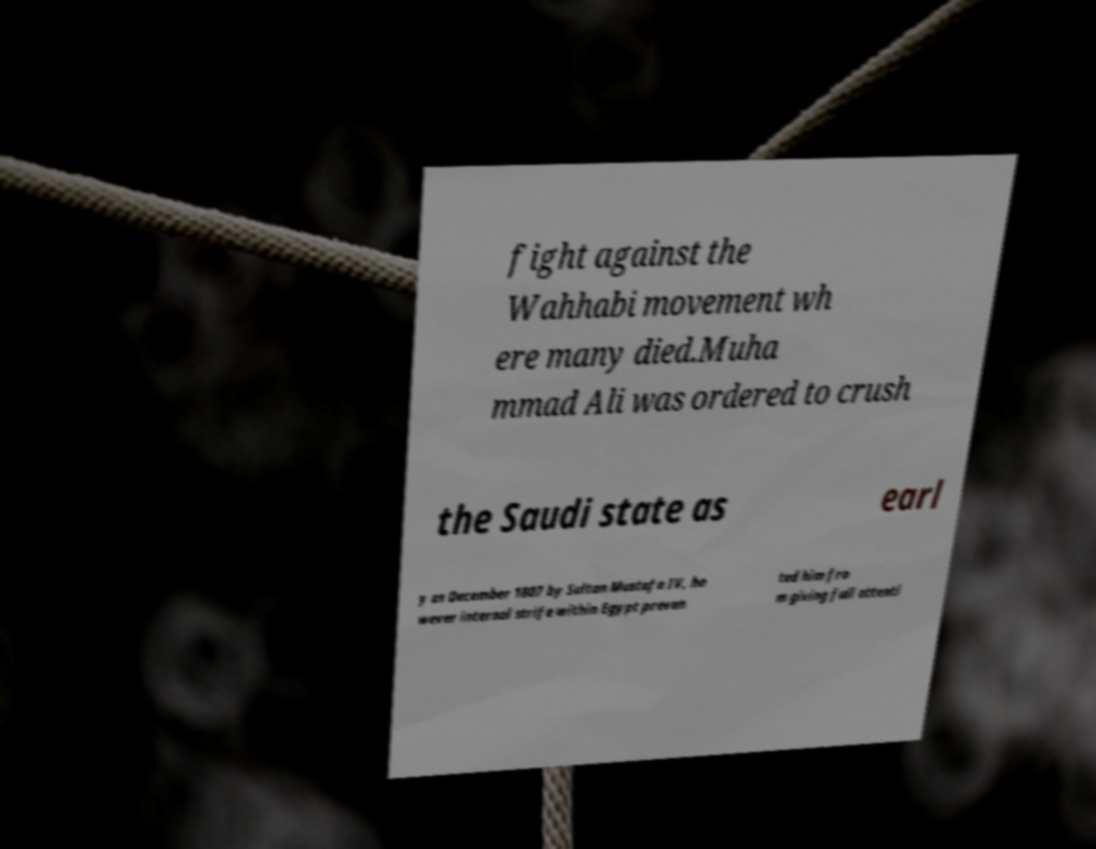Could you assist in decoding the text presented in this image and type it out clearly? fight against the Wahhabi movement wh ere many died.Muha mmad Ali was ordered to crush the Saudi state as earl y as December 1807 by Sultan Mustafa IV, ho wever internal strife within Egypt preven ted him fro m giving full attenti 